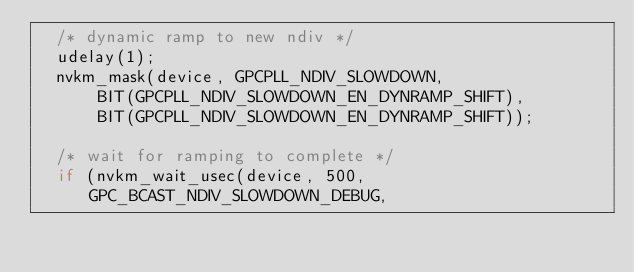<code> <loc_0><loc_0><loc_500><loc_500><_C_>	/* dynamic ramp to new ndiv */
	udelay(1);
	nvkm_mask(device, GPCPLL_NDIV_SLOWDOWN,
		  BIT(GPCPLL_NDIV_SLOWDOWN_EN_DYNRAMP_SHIFT),
		  BIT(GPCPLL_NDIV_SLOWDOWN_EN_DYNRAMP_SHIFT));

	/* wait for ramping to complete */
	if (nvkm_wait_usec(device, 500, GPC_BCAST_NDIV_SLOWDOWN_DEBUG,</code> 